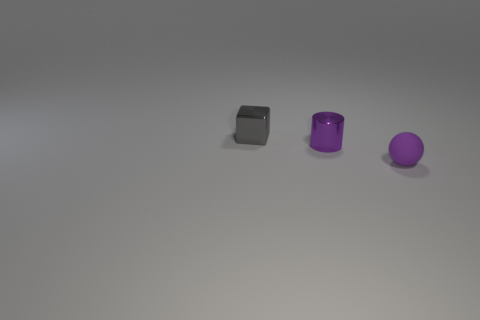Add 3 yellow matte cubes. How many objects exist? 6 Subtract 0 brown cylinders. How many objects are left? 3 Subtract all cubes. How many objects are left? 2 Subtract 1 cubes. How many cubes are left? 0 Subtract all cyan cylinders. Subtract all red balls. How many cylinders are left? 1 Subtract all purple spheres. How many cyan cubes are left? 0 Subtract all tiny gray cylinders. Subtract all purple balls. How many objects are left? 2 Add 3 metal cylinders. How many metal cylinders are left? 4 Add 1 gray objects. How many gray objects exist? 2 